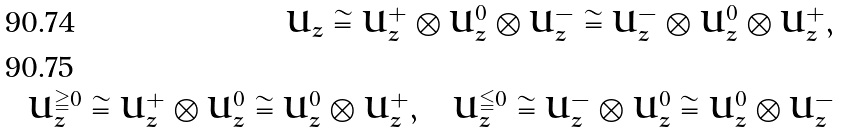<formula> <loc_0><loc_0><loc_500><loc_500>U _ { z } \cong U _ { z } ^ { + } \otimes U _ { z } ^ { 0 } \otimes U _ { z } ^ { - } \cong U _ { z } ^ { - } \otimes U _ { z } ^ { 0 } \otimes U _ { z } ^ { + } , \\ U _ { z } ^ { \geqq 0 } \cong U _ { z } ^ { + } \otimes U _ { z } ^ { 0 } \cong U _ { z } ^ { 0 } \otimes U _ { z } ^ { + } , \quad U _ { z } ^ { \leqq 0 } \cong U _ { z } ^ { - } \otimes U _ { z } ^ { 0 } \cong U _ { z } ^ { 0 } \otimes U _ { z } ^ { - }</formula> 